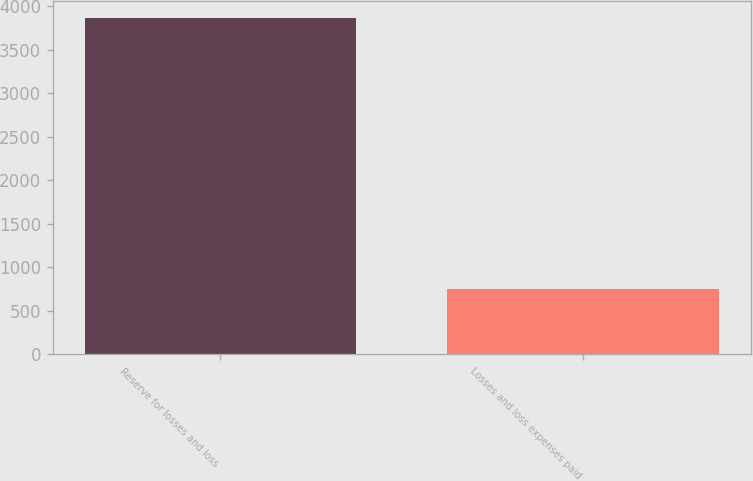Convert chart to OTSL. <chart><loc_0><loc_0><loc_500><loc_500><bar_chart><fcel>Reserve for losses and loss<fcel>Losses and loss expenses paid<nl><fcel>3864<fcel>755<nl></chart> 